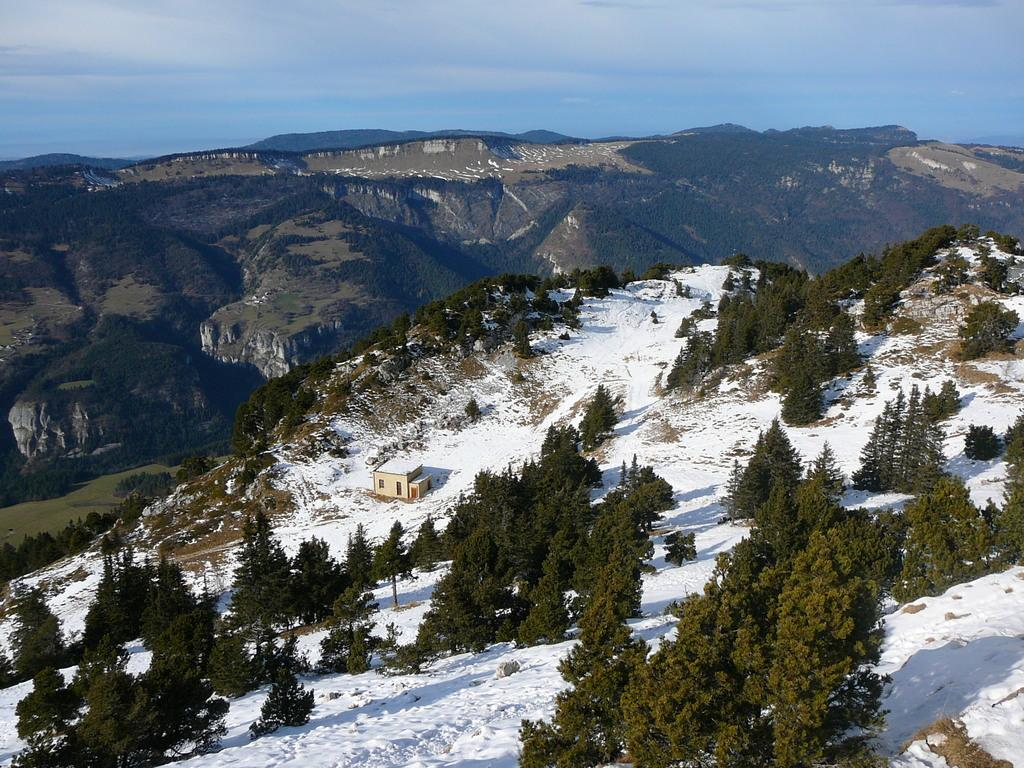What type of vegetation can be seen in the image? There are trees in the image. What geographical features are present in the middle of the image? There are hills in the middle of the image. What is visible at the top of the image? The sky is visible at the top of the image. What type of brush can be seen on the plate in the image? There is no brush or plate present in the image. How many bodies are visible in the image? There are no bodies visible in the image; it features trees, hills, and the sky. 